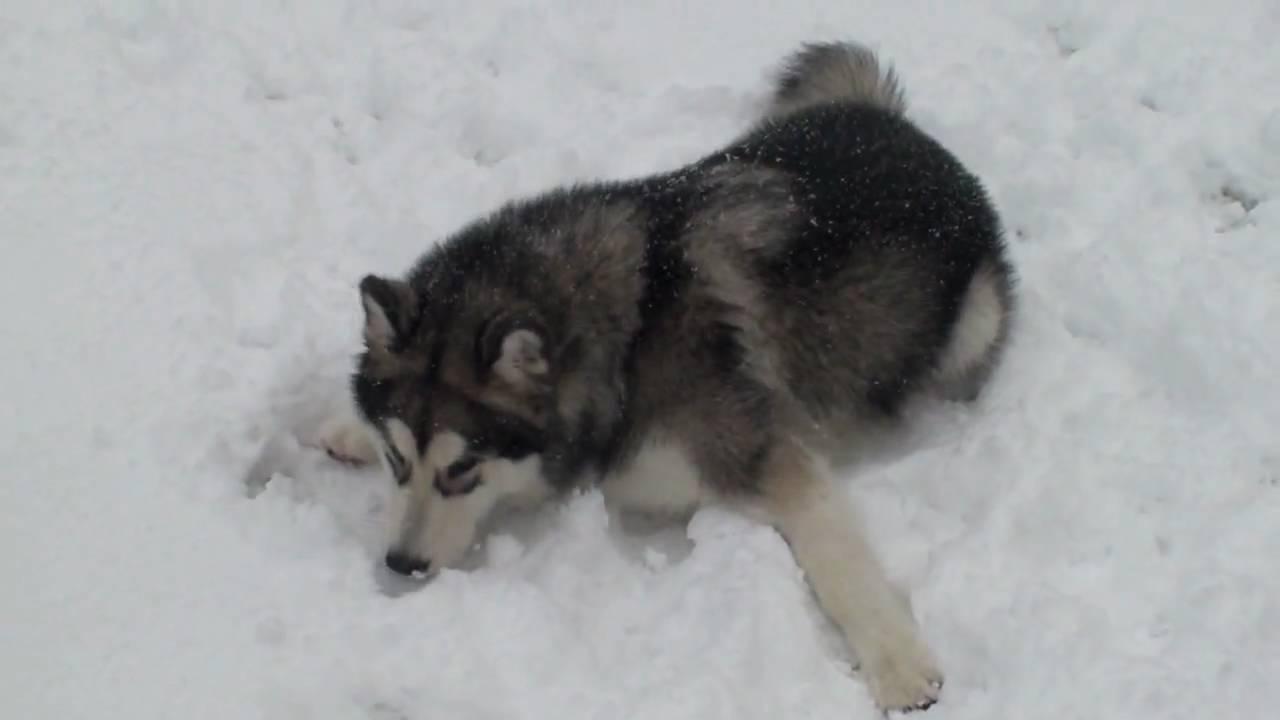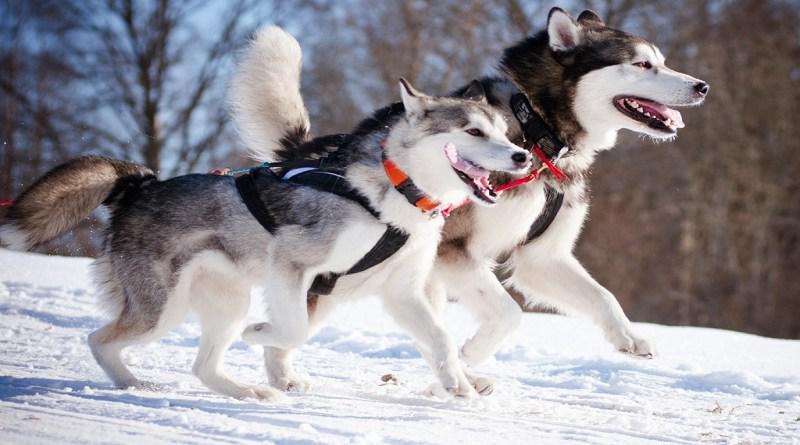The first image is the image on the left, the second image is the image on the right. Given the left and right images, does the statement "One of the images contains exactly two dogs." hold true? Answer yes or no. Yes. The first image is the image on the left, the second image is the image on the right. Considering the images on both sides, is "There are at most three dogs in total." valid? Answer yes or no. Yes. 